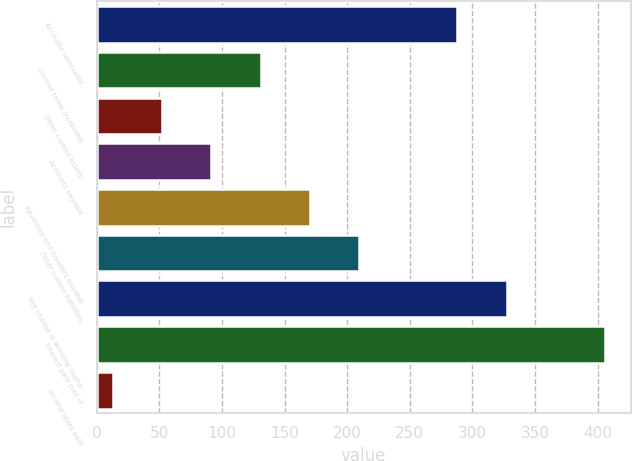<chart> <loc_0><loc_0><loc_500><loc_500><bar_chart><fcel>Accounts receivable<fcel>Income taxes receivable<fcel>Other current assets<fcel>Accounts payable<fcel>Revenues and royalties payable<fcel>Other current liabilities<fcel>Net change in working capital<fcel>Interest paid (net of<fcel>Income taxes paid<nl><fcel>288<fcel>130.9<fcel>52.3<fcel>91.6<fcel>170.2<fcel>209.5<fcel>327.3<fcel>406<fcel>13<nl></chart> 